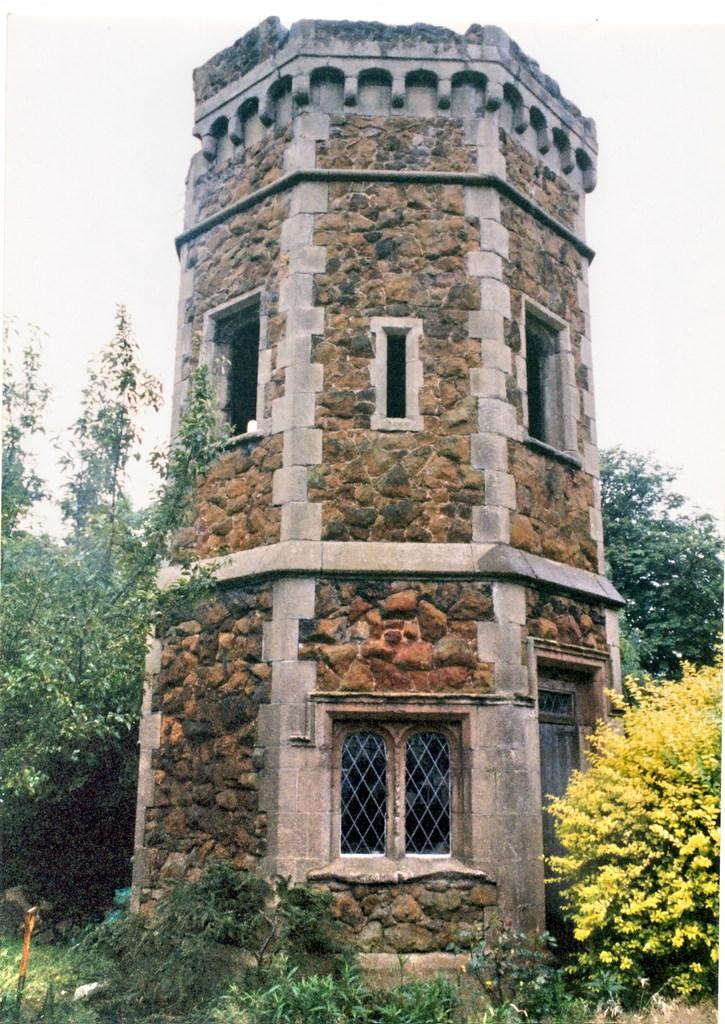What is the main structure in the center of the image? There is a fort in the center of the image. What features can be seen on the fort? The fort has windows. What can be seen in the background of the image? There are trees, plants, and a rod visible in the background. What is visible at the top of the image? The sky is visible at the top of the image. Can you tell me how many breaths the goat takes in the image? There is no goat present in the image, so it is not possible to determine the number of breaths it takes. What type of giants can be seen in the image? There are no giants present in the image. 